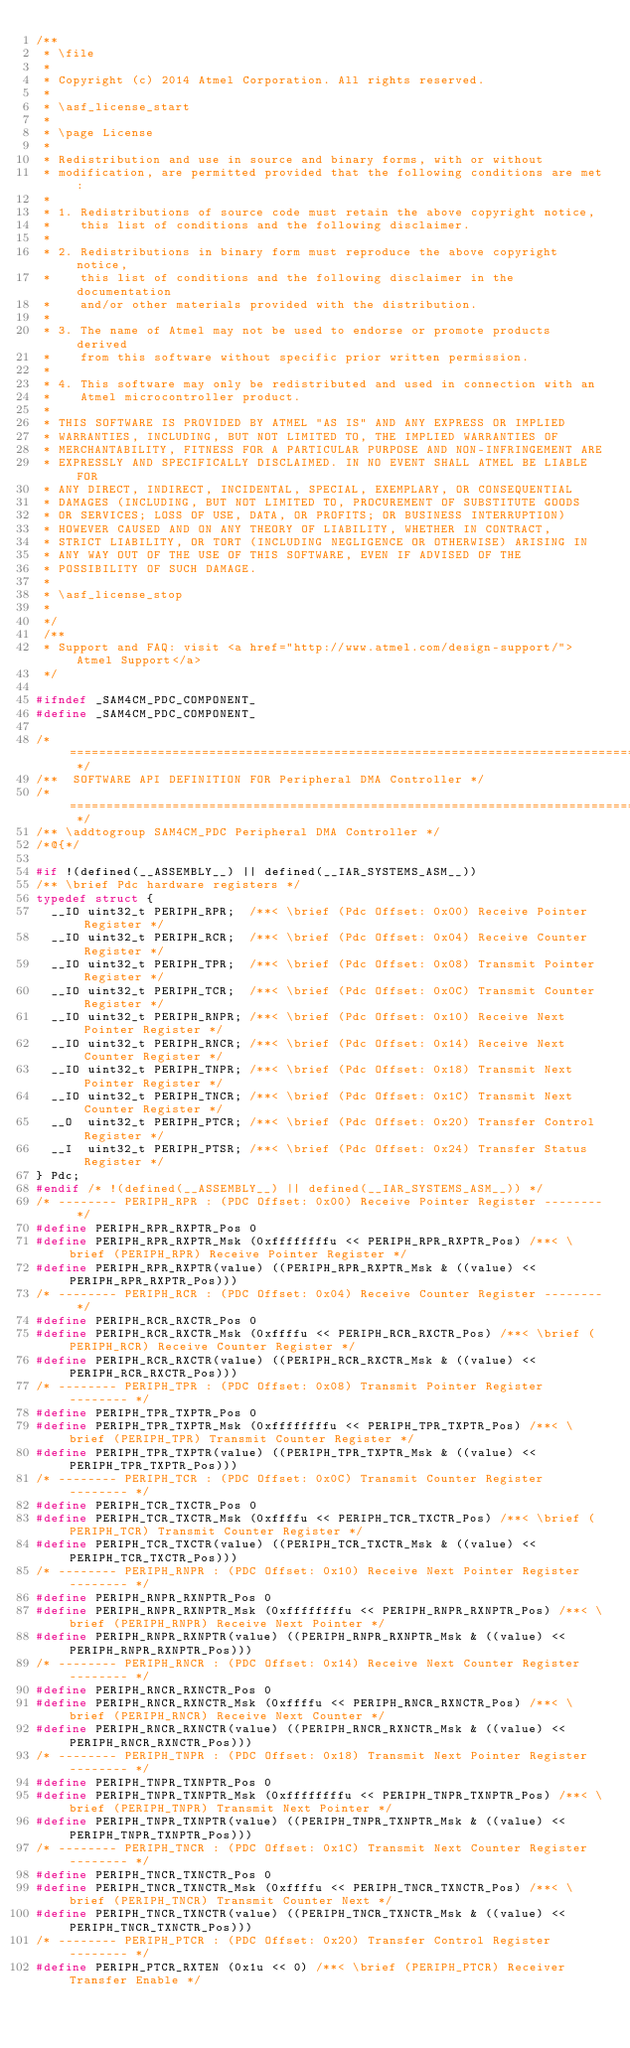<code> <loc_0><loc_0><loc_500><loc_500><_C_>/**
 * \file
 *
 * Copyright (c) 2014 Atmel Corporation. All rights reserved.
 *
 * \asf_license_start
 *
 * \page License
 *
 * Redistribution and use in source and binary forms, with or without
 * modification, are permitted provided that the following conditions are met:
 *
 * 1. Redistributions of source code must retain the above copyright notice,
 *    this list of conditions and the following disclaimer.
 *
 * 2. Redistributions in binary form must reproduce the above copyright notice,
 *    this list of conditions and the following disclaimer in the documentation
 *    and/or other materials provided with the distribution.
 *
 * 3. The name of Atmel may not be used to endorse or promote products derived
 *    from this software without specific prior written permission.
 *
 * 4. This software may only be redistributed and used in connection with an
 *    Atmel microcontroller product.
 *
 * THIS SOFTWARE IS PROVIDED BY ATMEL "AS IS" AND ANY EXPRESS OR IMPLIED
 * WARRANTIES, INCLUDING, BUT NOT LIMITED TO, THE IMPLIED WARRANTIES OF
 * MERCHANTABILITY, FITNESS FOR A PARTICULAR PURPOSE AND NON-INFRINGEMENT ARE
 * EXPRESSLY AND SPECIFICALLY DISCLAIMED. IN NO EVENT SHALL ATMEL BE LIABLE FOR
 * ANY DIRECT, INDIRECT, INCIDENTAL, SPECIAL, EXEMPLARY, OR CONSEQUENTIAL
 * DAMAGES (INCLUDING, BUT NOT LIMITED TO, PROCUREMENT OF SUBSTITUTE GOODS
 * OR SERVICES; LOSS OF USE, DATA, OR PROFITS; OR BUSINESS INTERRUPTION)
 * HOWEVER CAUSED AND ON ANY THEORY OF LIABILITY, WHETHER IN CONTRACT,
 * STRICT LIABILITY, OR TORT (INCLUDING NEGLIGENCE OR OTHERWISE) ARISING IN
 * ANY WAY OUT OF THE USE OF THIS SOFTWARE, EVEN IF ADVISED OF THE
 * POSSIBILITY OF SUCH DAMAGE.
 *
 * \asf_license_stop
 *
 */
 /**
 * Support and FAQ: visit <a href="http://www.atmel.com/design-support/">Atmel Support</a>
 */

#ifndef _SAM4CM_PDC_COMPONENT_
#define _SAM4CM_PDC_COMPONENT_

/* ============================================================================= */
/**  SOFTWARE API DEFINITION FOR Peripheral DMA Controller */
/* ============================================================================= */
/** \addtogroup SAM4CM_PDC Peripheral DMA Controller */
/*@{*/

#if !(defined(__ASSEMBLY__) || defined(__IAR_SYSTEMS_ASM__))
/** \brief Pdc hardware registers */
typedef struct {
  __IO uint32_t PERIPH_RPR;  /**< \brief (Pdc Offset: 0x00) Receive Pointer Register */
  __IO uint32_t PERIPH_RCR;  /**< \brief (Pdc Offset: 0x04) Receive Counter Register */
  __IO uint32_t PERIPH_TPR;  /**< \brief (Pdc Offset: 0x08) Transmit Pointer Register */
  __IO uint32_t PERIPH_TCR;  /**< \brief (Pdc Offset: 0x0C) Transmit Counter Register */
  __IO uint32_t PERIPH_RNPR; /**< \brief (Pdc Offset: 0x10) Receive Next Pointer Register */
  __IO uint32_t PERIPH_RNCR; /**< \brief (Pdc Offset: 0x14) Receive Next Counter Register */
  __IO uint32_t PERIPH_TNPR; /**< \brief (Pdc Offset: 0x18) Transmit Next Pointer Register */
  __IO uint32_t PERIPH_TNCR; /**< \brief (Pdc Offset: 0x1C) Transmit Next Counter Register */
  __O  uint32_t PERIPH_PTCR; /**< \brief (Pdc Offset: 0x20) Transfer Control Register */
  __I  uint32_t PERIPH_PTSR; /**< \brief (Pdc Offset: 0x24) Transfer Status Register */
} Pdc;
#endif /* !(defined(__ASSEMBLY__) || defined(__IAR_SYSTEMS_ASM__)) */
/* -------- PERIPH_RPR : (PDC Offset: 0x00) Receive Pointer Register -------- */
#define PERIPH_RPR_RXPTR_Pos 0
#define PERIPH_RPR_RXPTR_Msk (0xffffffffu << PERIPH_RPR_RXPTR_Pos) /**< \brief (PERIPH_RPR) Receive Pointer Register */
#define PERIPH_RPR_RXPTR(value) ((PERIPH_RPR_RXPTR_Msk & ((value) << PERIPH_RPR_RXPTR_Pos)))
/* -------- PERIPH_RCR : (PDC Offset: 0x04) Receive Counter Register -------- */
#define PERIPH_RCR_RXCTR_Pos 0
#define PERIPH_RCR_RXCTR_Msk (0xffffu << PERIPH_RCR_RXCTR_Pos) /**< \brief (PERIPH_RCR) Receive Counter Register */
#define PERIPH_RCR_RXCTR(value) ((PERIPH_RCR_RXCTR_Msk & ((value) << PERIPH_RCR_RXCTR_Pos)))
/* -------- PERIPH_TPR : (PDC Offset: 0x08) Transmit Pointer Register -------- */
#define PERIPH_TPR_TXPTR_Pos 0
#define PERIPH_TPR_TXPTR_Msk (0xffffffffu << PERIPH_TPR_TXPTR_Pos) /**< \brief (PERIPH_TPR) Transmit Counter Register */
#define PERIPH_TPR_TXPTR(value) ((PERIPH_TPR_TXPTR_Msk & ((value) << PERIPH_TPR_TXPTR_Pos)))
/* -------- PERIPH_TCR : (PDC Offset: 0x0C) Transmit Counter Register -------- */
#define PERIPH_TCR_TXCTR_Pos 0
#define PERIPH_TCR_TXCTR_Msk (0xffffu << PERIPH_TCR_TXCTR_Pos) /**< \brief (PERIPH_TCR) Transmit Counter Register */
#define PERIPH_TCR_TXCTR(value) ((PERIPH_TCR_TXCTR_Msk & ((value) << PERIPH_TCR_TXCTR_Pos)))
/* -------- PERIPH_RNPR : (PDC Offset: 0x10) Receive Next Pointer Register -------- */
#define PERIPH_RNPR_RXNPTR_Pos 0
#define PERIPH_RNPR_RXNPTR_Msk (0xffffffffu << PERIPH_RNPR_RXNPTR_Pos) /**< \brief (PERIPH_RNPR) Receive Next Pointer */
#define PERIPH_RNPR_RXNPTR(value) ((PERIPH_RNPR_RXNPTR_Msk & ((value) << PERIPH_RNPR_RXNPTR_Pos)))
/* -------- PERIPH_RNCR : (PDC Offset: 0x14) Receive Next Counter Register -------- */
#define PERIPH_RNCR_RXNCTR_Pos 0
#define PERIPH_RNCR_RXNCTR_Msk (0xffffu << PERIPH_RNCR_RXNCTR_Pos) /**< \brief (PERIPH_RNCR) Receive Next Counter */
#define PERIPH_RNCR_RXNCTR(value) ((PERIPH_RNCR_RXNCTR_Msk & ((value) << PERIPH_RNCR_RXNCTR_Pos)))
/* -------- PERIPH_TNPR : (PDC Offset: 0x18) Transmit Next Pointer Register -------- */
#define PERIPH_TNPR_TXNPTR_Pos 0
#define PERIPH_TNPR_TXNPTR_Msk (0xffffffffu << PERIPH_TNPR_TXNPTR_Pos) /**< \brief (PERIPH_TNPR) Transmit Next Pointer */
#define PERIPH_TNPR_TXNPTR(value) ((PERIPH_TNPR_TXNPTR_Msk & ((value) << PERIPH_TNPR_TXNPTR_Pos)))
/* -------- PERIPH_TNCR : (PDC Offset: 0x1C) Transmit Next Counter Register -------- */
#define PERIPH_TNCR_TXNCTR_Pos 0
#define PERIPH_TNCR_TXNCTR_Msk (0xffffu << PERIPH_TNCR_TXNCTR_Pos) /**< \brief (PERIPH_TNCR) Transmit Counter Next */
#define PERIPH_TNCR_TXNCTR(value) ((PERIPH_TNCR_TXNCTR_Msk & ((value) << PERIPH_TNCR_TXNCTR_Pos)))
/* -------- PERIPH_PTCR : (PDC Offset: 0x20) Transfer Control Register -------- */
#define PERIPH_PTCR_RXTEN (0x1u << 0) /**< \brief (PERIPH_PTCR) Receiver Transfer Enable */</code> 